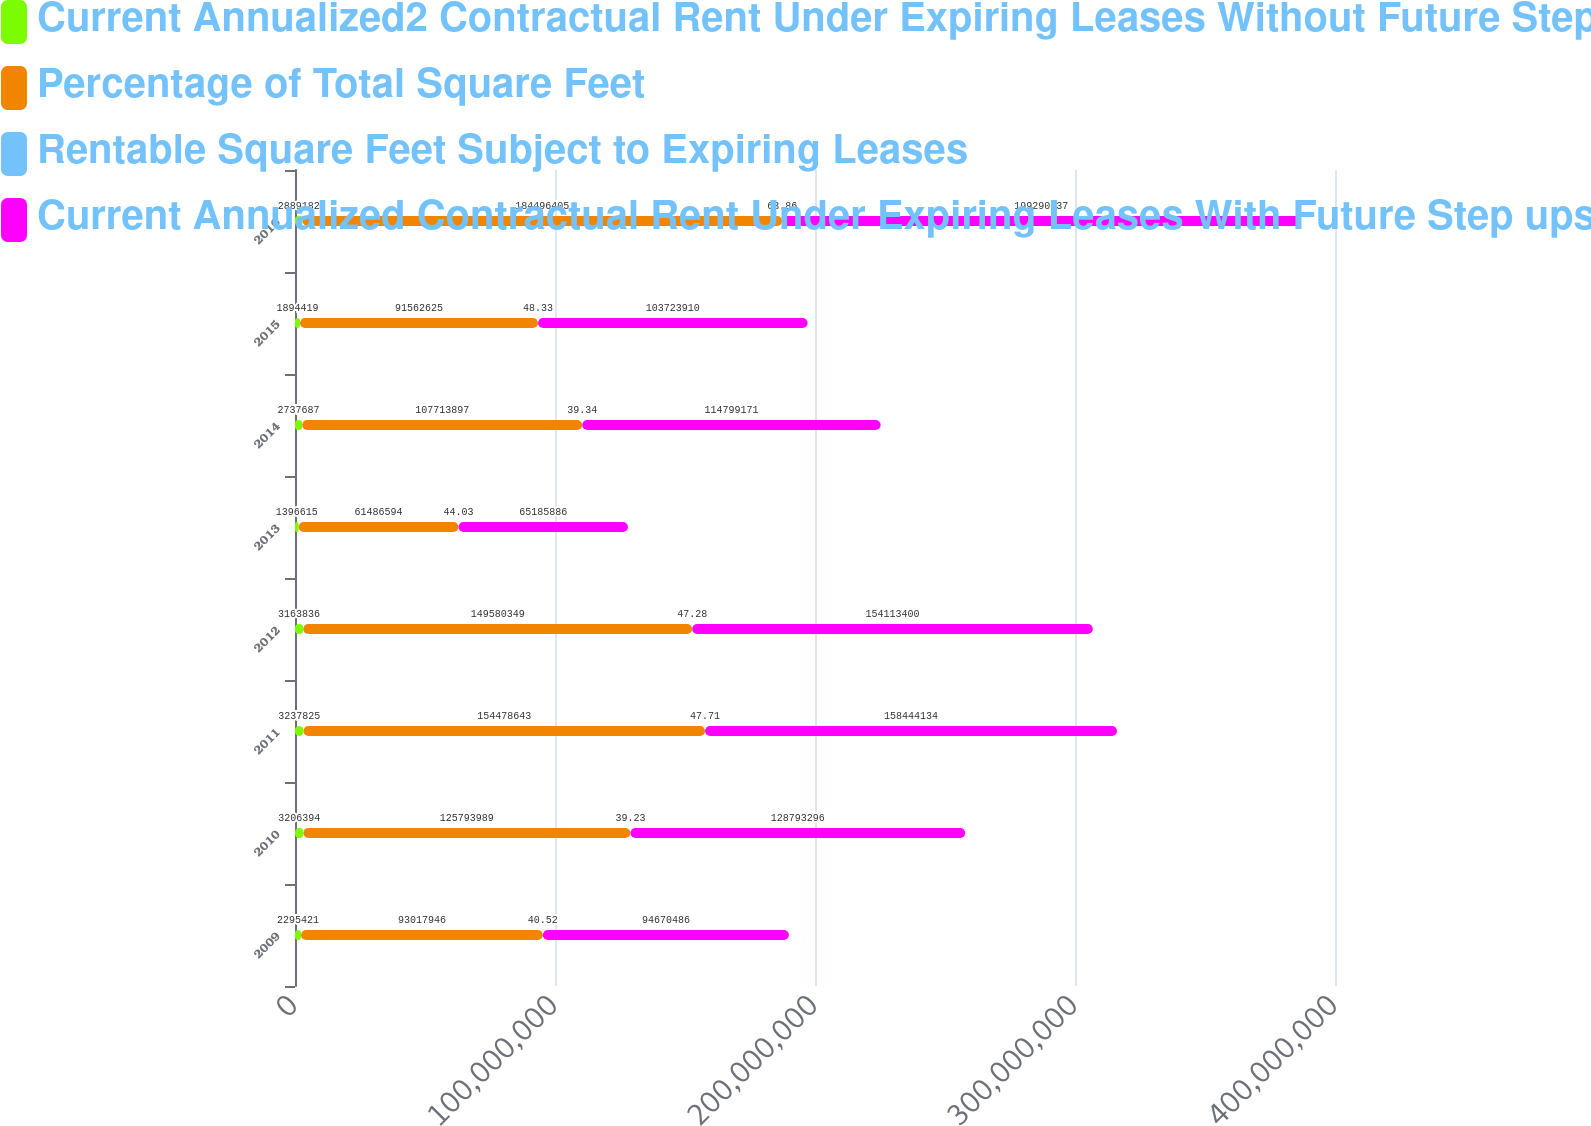<chart> <loc_0><loc_0><loc_500><loc_500><stacked_bar_chart><ecel><fcel>2009<fcel>2010<fcel>2011<fcel>2012<fcel>2013<fcel>2014<fcel>2015<fcel>2016<nl><fcel>Current Annualized2 Contractual Rent Under Expiring Leases Without Future StepUps<fcel>2.29542e+06<fcel>3.20639e+06<fcel>3.23782e+06<fcel>3.16384e+06<fcel>1.39662e+06<fcel>2.73769e+06<fcel>1.89442e+06<fcel>2.88918e+06<nl><fcel>Percentage of Total Square Feet<fcel>9.30179e+07<fcel>1.25794e+08<fcel>1.54479e+08<fcel>1.4958e+08<fcel>6.14866e+07<fcel>1.07714e+08<fcel>9.15626e+07<fcel>1.84496e+08<nl><fcel>Rentable Square Feet Subject to Expiring Leases<fcel>40.52<fcel>39.23<fcel>47.71<fcel>47.28<fcel>44.03<fcel>39.34<fcel>48.33<fcel>63.86<nl><fcel>Current Annualized Contractual Rent Under Expiring Leases With Future Step ups p.s.f.3<fcel>9.46705e+07<fcel>1.28793e+08<fcel>1.58444e+08<fcel>1.54113e+08<fcel>6.51859e+07<fcel>1.14799e+08<fcel>1.03724e+08<fcel>1.99291e+08<nl></chart> 